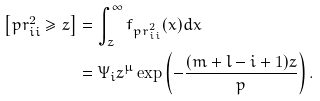Convert formula to latex. <formula><loc_0><loc_0><loc_500><loc_500>\left [ p r ^ { 2 } _ { i i } \geq z \right ] & = \int ^ { \infty } _ { z } f _ { p r ^ { 2 } _ { i i } } ( x ) d x \\ & = \Psi _ { i } z ^ { \mu } \exp \left ( - \frac { ( m + l - i + 1 ) z } { p } \right ) .</formula> 